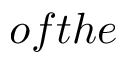<formula> <loc_0><loc_0><loc_500><loc_500>o f t h e</formula> 